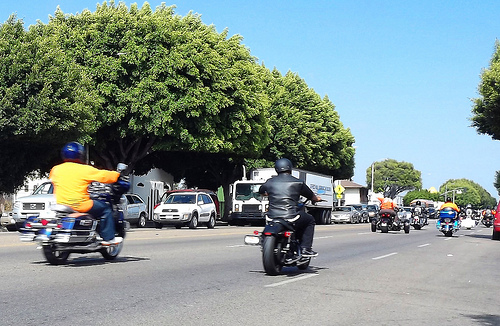<image>
Is the tree behind the truck? Yes. From this viewpoint, the tree is positioned behind the truck, with the truck partially or fully occluding the tree. 